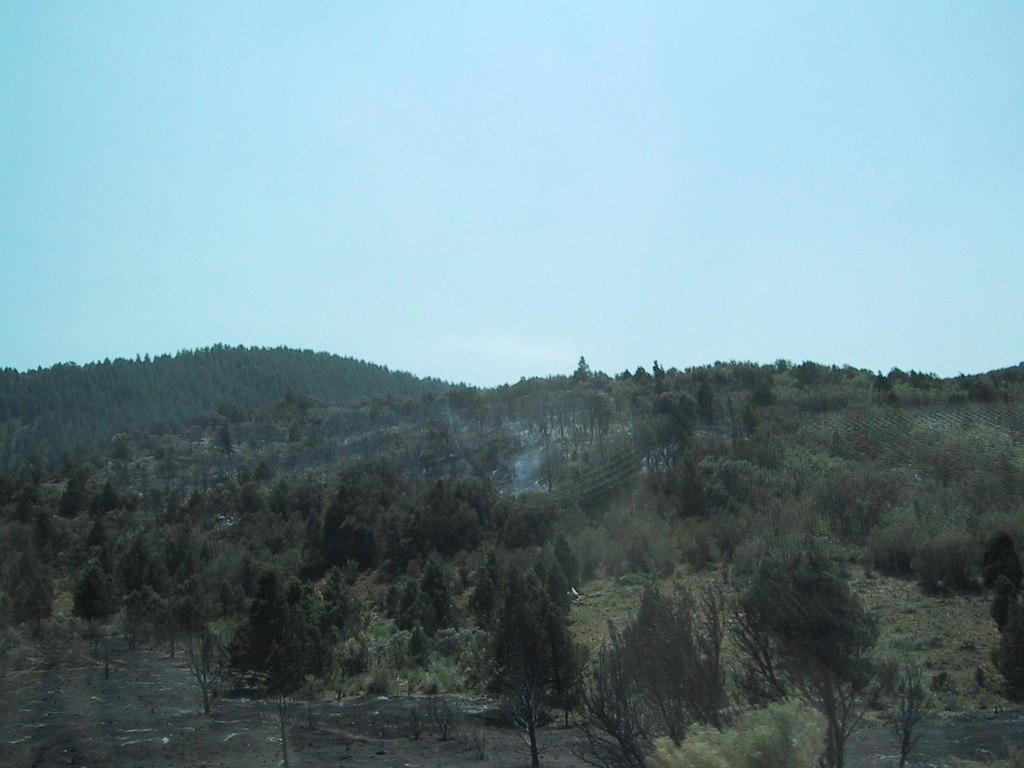Describe this image in one or two sentences. In the picture I can see trees, the grass and plants. In the background I can see the sky. 